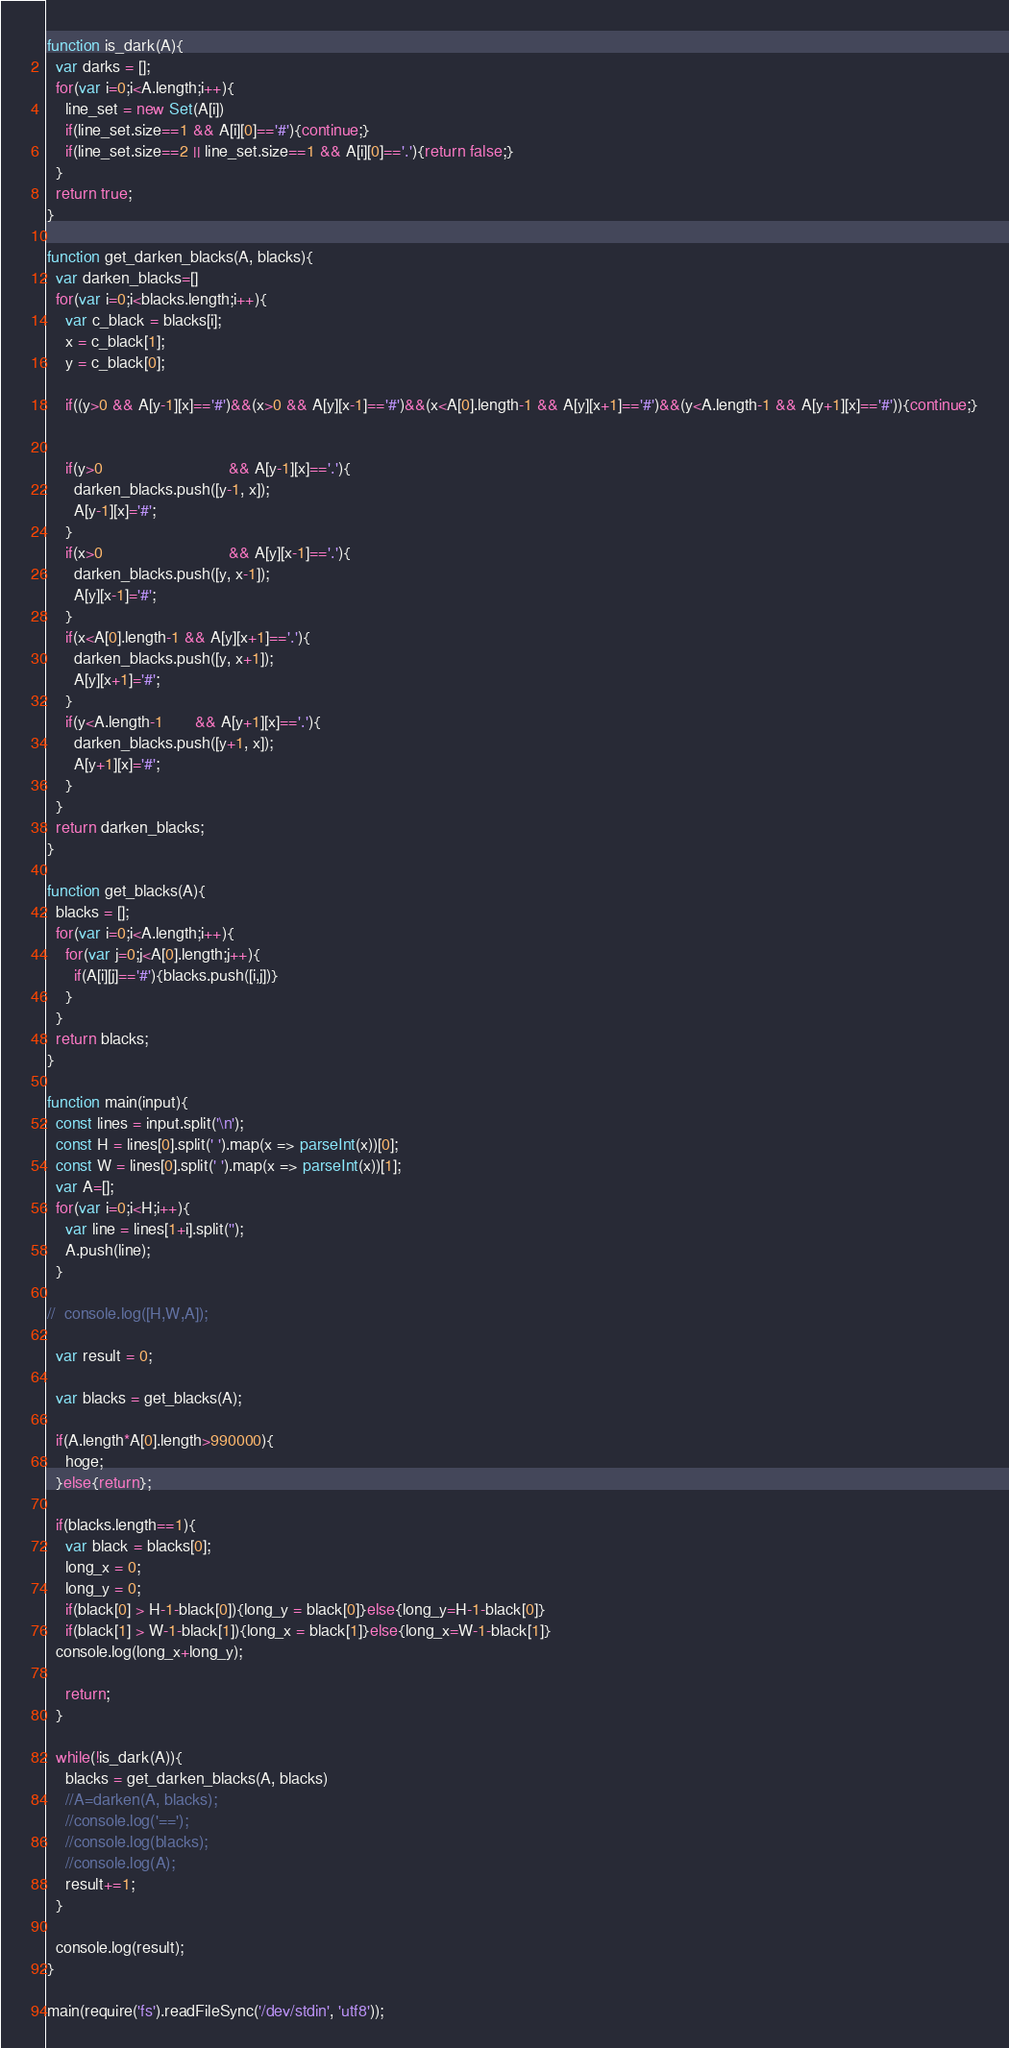<code> <loc_0><loc_0><loc_500><loc_500><_TypeScript_>function is_dark(A){
  var darks = [];
  for(var i=0;i<A.length;i++){
    line_set = new Set(A[i])
    if(line_set.size==1 && A[i][0]=='#'){continue;}
    if(line_set.size==2 || line_set.size==1 && A[i][0]=='.'){return false;}
  }
  return true;
}

function get_darken_blacks(A, blacks){
  var darken_blacks=[]
  for(var i=0;i<blacks.length;i++){
    var c_black = blacks[i];
    x = c_black[1];
    y = c_black[0];

    if((y>0 && A[y-1][x]=='#')&&(x>0 && A[y][x-1]=='#')&&(x<A[0].length-1 && A[y][x+1]=='#')&&(y<A.length-1 && A[y+1][x]=='#')){continue;}


    if(y>0                            && A[y-1][x]=='.'){
      darken_blacks.push([y-1, x]);
      A[y-1][x]='#';
    }
    if(x>0                            && A[y][x-1]=='.'){
      darken_blacks.push([y, x-1]);
      A[y][x-1]='#';
    }
    if(x<A[0].length-1 && A[y][x+1]=='.'){
      darken_blacks.push([y, x+1]);
      A[y][x+1]='#';
    }
    if(y<A.length-1       && A[y+1][x]=='.'){
      darken_blacks.push([y+1, x]);
      A[y+1][x]='#';
    }
  }
  return darken_blacks;
}

function get_blacks(A){
  blacks = [];
  for(var i=0;i<A.length;i++){
    for(var j=0;j<A[0].length;j++){
      if(A[i][j]=='#'){blacks.push([i,j])}
    }
  }
  return blacks;
}

function main(input){
  const lines = input.split('\n');
  const H = lines[0].split(' ').map(x => parseInt(x))[0];
  const W = lines[0].split(' ').map(x => parseInt(x))[1];
  var A=[];
  for(var i=0;i<H;i++){
    var line = lines[1+i].split('');
    A.push(line);
  }

//  console.log([H,W,A]);

  var result = 0;

  var blacks = get_blacks(A);

  if(A.length*A[0].length>990000){
    hoge;
  }else{return};

  if(blacks.length==1){
    var black = blacks[0];
    long_x = 0;
    long_y = 0;
    if(black[0] > H-1-black[0]){long_y = black[0]}else{long_y=H-1-black[0]}
    if(black[1] > W-1-black[1]){long_x = black[1]}else{long_x=W-1-black[1]}
  console.log(long_x+long_y);

    return;
  }

  while(!is_dark(A)){
    blacks = get_darken_blacks(A, blacks)
    //A=darken(A, blacks);
    //console.log('==');
    //console.log(blacks);
    //console.log(A);
    result+=1;
  }

  console.log(result);
}

main(require('fs').readFileSync('/dev/stdin', 'utf8'));
</code> 